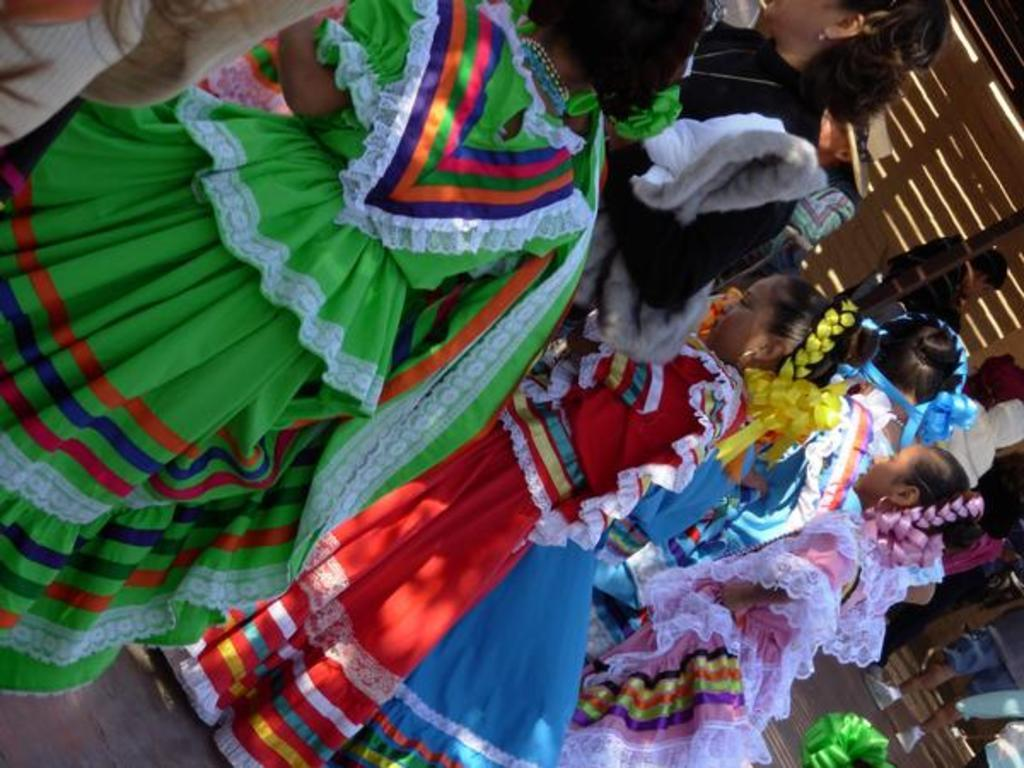What is happening in the middle of the image? There are persons standing in the middle of the image. What is happening in the bottom right side of the image? There are people walking in the bottom right side of the image. What can be seen in the top right side of the image? There is a wall in the top right side of the image. Can you tell me how many receipts are visible in the image? There are no receipts present in the image. What type of cannon is being fired in the image? There is no cannon present in the image. 